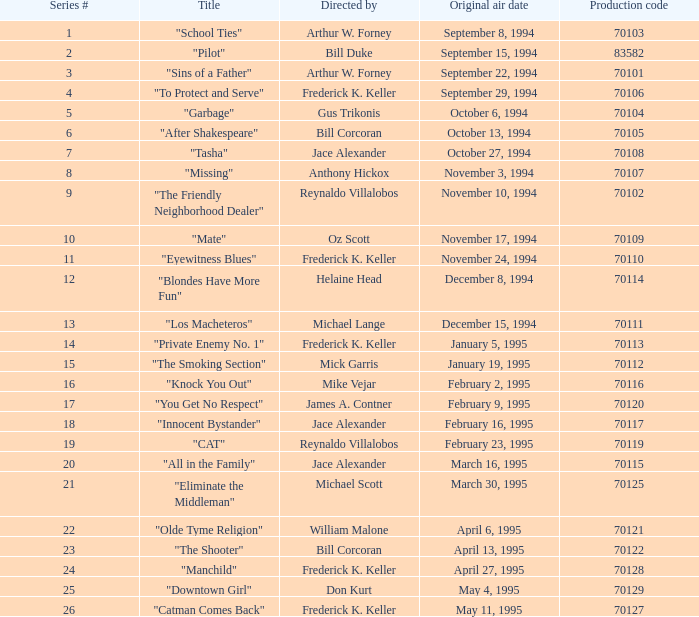Can you give me this table as a dict? {'header': ['Series #', 'Title', 'Directed by', 'Original air date', 'Production code'], 'rows': [['1', '"School Ties"', 'Arthur W. Forney', 'September 8, 1994', '70103'], ['2', '"Pilot"', 'Bill Duke', 'September 15, 1994', '83582'], ['3', '"Sins of a Father"', 'Arthur W. Forney', 'September 22, 1994', '70101'], ['4', '"To Protect and Serve"', 'Frederick K. Keller', 'September 29, 1994', '70106'], ['5', '"Garbage"', 'Gus Trikonis', 'October 6, 1994', '70104'], ['6', '"After Shakespeare"', 'Bill Corcoran', 'October 13, 1994', '70105'], ['7', '"Tasha"', 'Jace Alexander', 'October 27, 1994', '70108'], ['8', '"Missing"', 'Anthony Hickox', 'November 3, 1994', '70107'], ['9', '"The Friendly Neighborhood Dealer"', 'Reynaldo Villalobos', 'November 10, 1994', '70102'], ['10', '"Mate"', 'Oz Scott', 'November 17, 1994', '70109'], ['11', '"Eyewitness Blues"', 'Frederick K. Keller', 'November 24, 1994', '70110'], ['12', '"Blondes Have More Fun"', 'Helaine Head', 'December 8, 1994', '70114'], ['13', '"Los Macheteros"', 'Michael Lange', 'December 15, 1994', '70111'], ['14', '"Private Enemy No. 1"', 'Frederick K. Keller', 'January 5, 1995', '70113'], ['15', '"The Smoking Section"', 'Mick Garris', 'January 19, 1995', '70112'], ['16', '"Knock You Out"', 'Mike Vejar', 'February 2, 1995', '70116'], ['17', '"You Get No Respect"', 'James A. Contner', 'February 9, 1995', '70120'], ['18', '"Innocent Bystander"', 'Jace Alexander', 'February 16, 1995', '70117'], ['19', '"CAT"', 'Reynaldo Villalobos', 'February 23, 1995', '70119'], ['20', '"All in the Family"', 'Jace Alexander', 'March 16, 1995', '70115'], ['21', '"Eliminate the Middleman"', 'Michael Scott', 'March 30, 1995', '70125'], ['22', '"Olde Tyme Religion"', 'William Malone', 'April 6, 1995', '70121'], ['23', '"The Shooter"', 'Bill Corcoran', 'April 13, 1995', '70122'], ['24', '"Manchild"', 'Frederick K. Keller', 'April 27, 1995', '70128'], ['25', '"Downtown Girl"', 'Don Kurt', 'May 4, 1995', '70129'], ['26', '"Catman Comes Back"', 'Frederick K. Keller', 'May 11, 1995', '70127']]} What was the lowest production code value in series #10? 70109.0. 